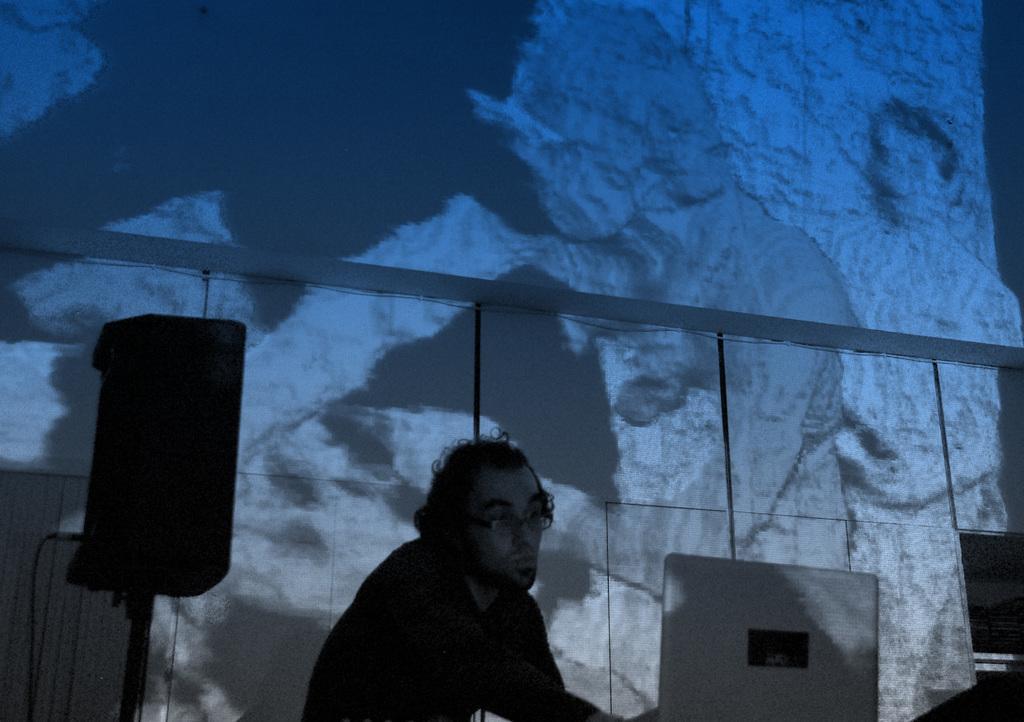Please provide a concise description of this image. In the foreground of this picture we can see a man seems to be sitting and we can see a speaker and a device seems to be the laptop. In the background there is an object which seems to be the screen and we can see some pictures on the screen. 